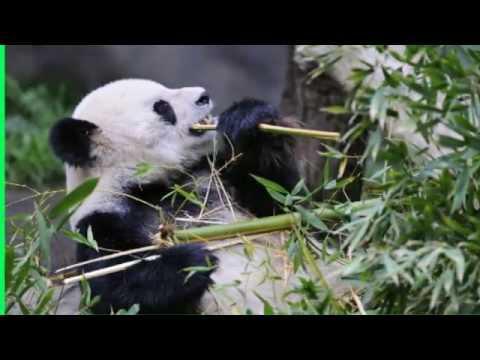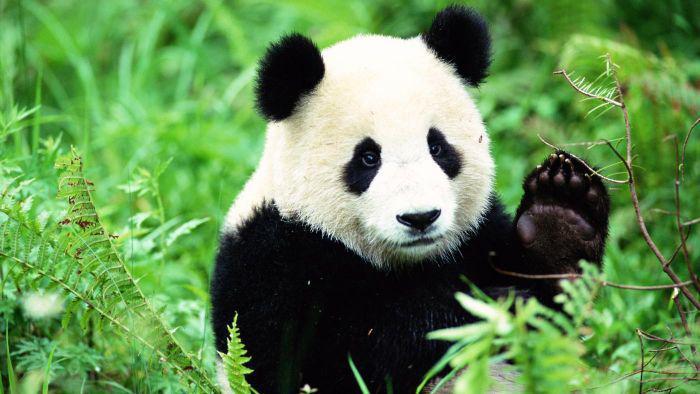The first image is the image on the left, the second image is the image on the right. Assess this claim about the two images: "there is a panda sitting on the ground in front of a fallen tree log with a standing tree trunk to the right of the panda". Correct or not? Answer yes or no. No. The first image is the image on the left, the second image is the image on the right. Considering the images on both sides, is "All pandas are grasping part of a bamboo plant, and at least one of the pandas depicted faces forward with his rightward elbow bent and paw raised to his mouth." valid? Answer yes or no. No. 